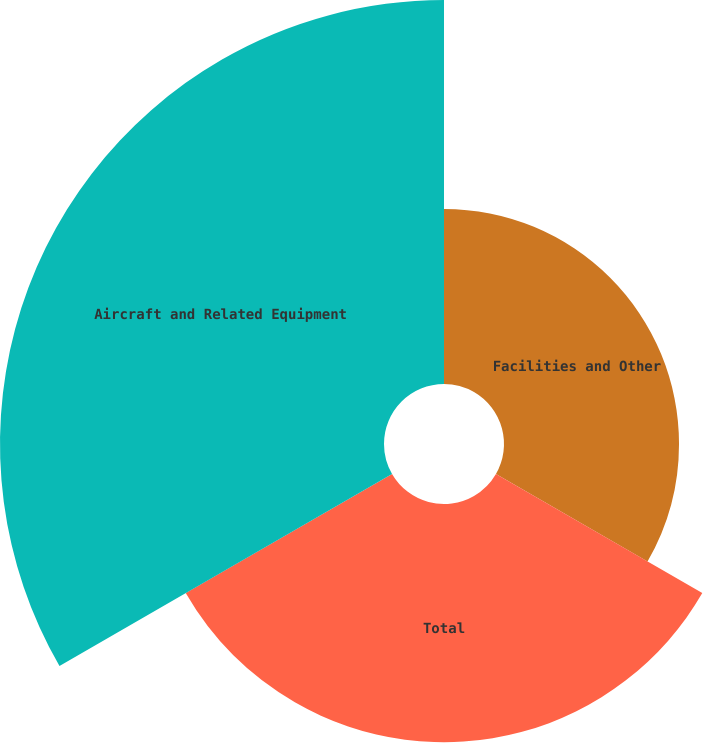Convert chart to OTSL. <chart><loc_0><loc_0><loc_500><loc_500><pie_chart><fcel>Facilities and Other<fcel>Total<fcel>Aircraft and Related Equipment<nl><fcel>21.95%<fcel>29.88%<fcel>48.16%<nl></chart> 